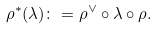Convert formula to latex. <formula><loc_0><loc_0><loc_500><loc_500>\rho ^ { * } ( \lambda ) \colon = \rho ^ { \vee } \circ \lambda \circ \rho .</formula> 